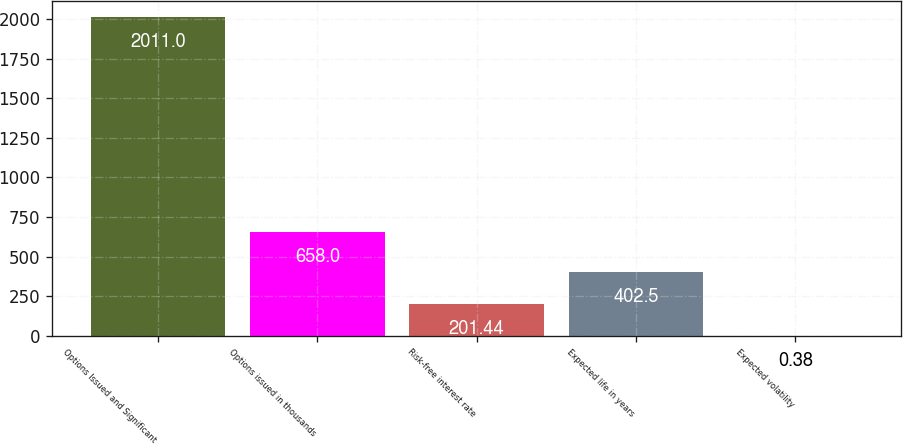Convert chart. <chart><loc_0><loc_0><loc_500><loc_500><bar_chart><fcel>Options Issued and Significant<fcel>Options issued in thousands<fcel>Risk-free interest rate<fcel>Expected life in years<fcel>Expected volatility<nl><fcel>2011<fcel>658<fcel>201.44<fcel>402.5<fcel>0.38<nl></chart> 